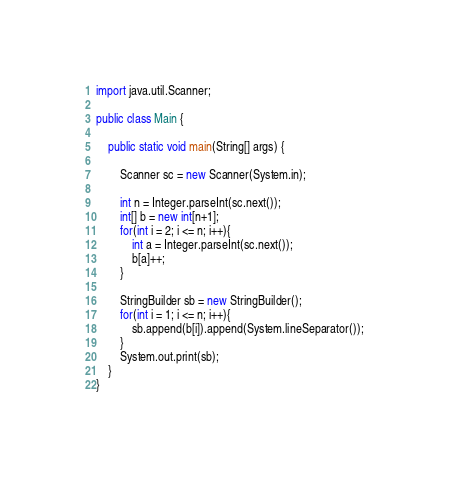Convert code to text. <code><loc_0><loc_0><loc_500><loc_500><_Java_>import java.util.Scanner;

public class Main {

    public static void main(String[] args) {
        
        Scanner sc = new Scanner(System.in);
        
        int n = Integer.parseInt(sc.next());
        int[] b = new int[n+1];
        for(int i = 2; i <= n; i++){
            int a = Integer.parseInt(sc.next());
            b[a]++;
        }
        
        StringBuilder sb = new StringBuilder();
        for(int i = 1; i <= n; i++){
            sb.append(b[i]).append(System.lineSeparator());
        }
        System.out.print(sb);
    }
}</code> 